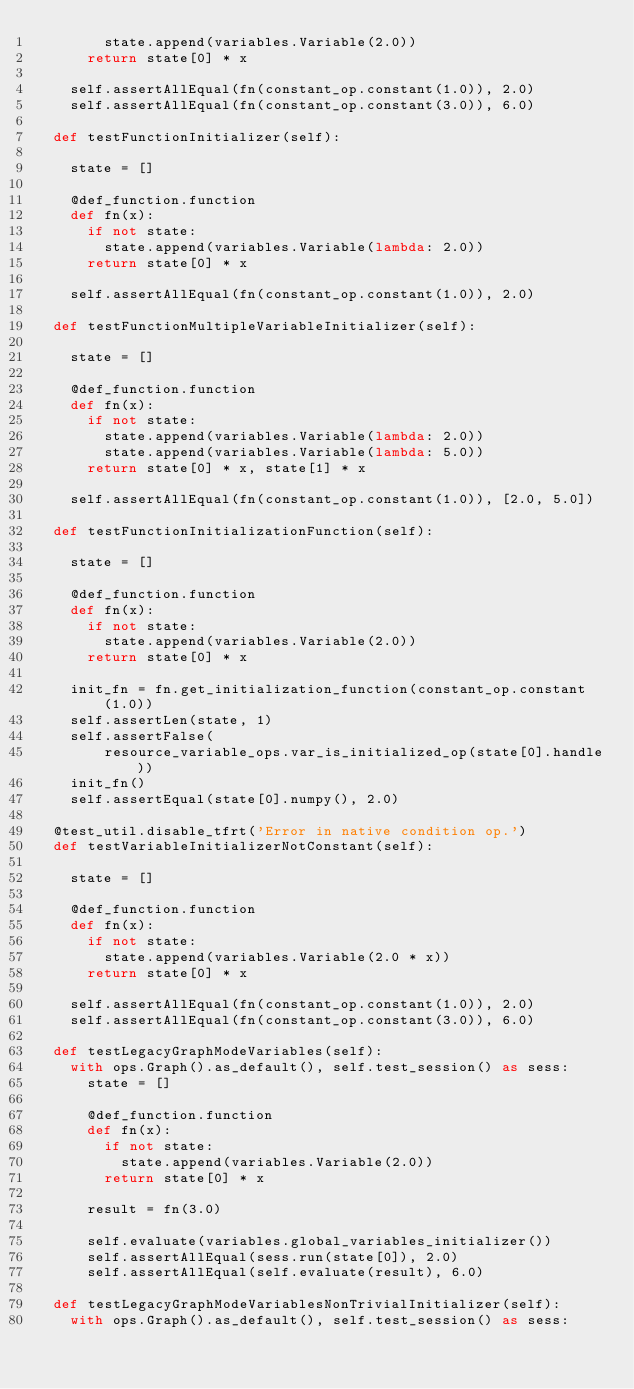Convert code to text. <code><loc_0><loc_0><loc_500><loc_500><_Python_>        state.append(variables.Variable(2.0))
      return state[0] * x

    self.assertAllEqual(fn(constant_op.constant(1.0)), 2.0)
    self.assertAllEqual(fn(constant_op.constant(3.0)), 6.0)

  def testFunctionInitializer(self):

    state = []

    @def_function.function
    def fn(x):
      if not state:
        state.append(variables.Variable(lambda: 2.0))
      return state[0] * x

    self.assertAllEqual(fn(constant_op.constant(1.0)), 2.0)

  def testFunctionMultipleVariableInitializer(self):

    state = []

    @def_function.function
    def fn(x):
      if not state:
        state.append(variables.Variable(lambda: 2.0))
        state.append(variables.Variable(lambda: 5.0))
      return state[0] * x, state[1] * x

    self.assertAllEqual(fn(constant_op.constant(1.0)), [2.0, 5.0])

  def testFunctionInitializationFunction(self):

    state = []

    @def_function.function
    def fn(x):
      if not state:
        state.append(variables.Variable(2.0))
      return state[0] * x

    init_fn = fn.get_initialization_function(constant_op.constant(1.0))
    self.assertLen(state, 1)
    self.assertFalse(
        resource_variable_ops.var_is_initialized_op(state[0].handle))
    init_fn()
    self.assertEqual(state[0].numpy(), 2.0)

  @test_util.disable_tfrt('Error in native condition op.')
  def testVariableInitializerNotConstant(self):

    state = []

    @def_function.function
    def fn(x):
      if not state:
        state.append(variables.Variable(2.0 * x))
      return state[0] * x

    self.assertAllEqual(fn(constant_op.constant(1.0)), 2.0)
    self.assertAllEqual(fn(constant_op.constant(3.0)), 6.0)

  def testLegacyGraphModeVariables(self):
    with ops.Graph().as_default(), self.test_session() as sess:
      state = []

      @def_function.function
      def fn(x):
        if not state:
          state.append(variables.Variable(2.0))
        return state[0] * x

      result = fn(3.0)

      self.evaluate(variables.global_variables_initializer())
      self.assertAllEqual(sess.run(state[0]), 2.0)
      self.assertAllEqual(self.evaluate(result), 6.0)

  def testLegacyGraphModeVariablesNonTrivialInitializer(self):
    with ops.Graph().as_default(), self.test_session() as sess:</code> 